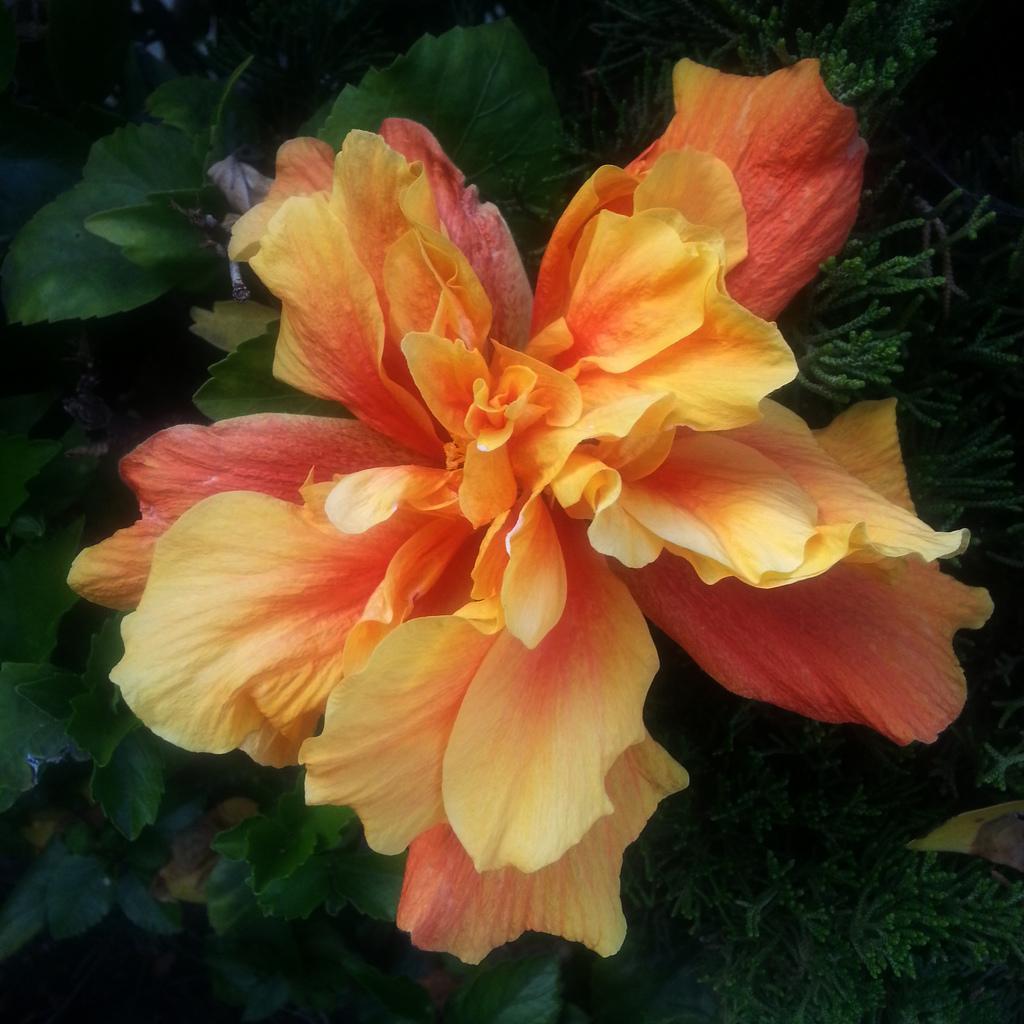In one or two sentences, can you explain what this image depicts? In this image we can see a flower and leaves. 